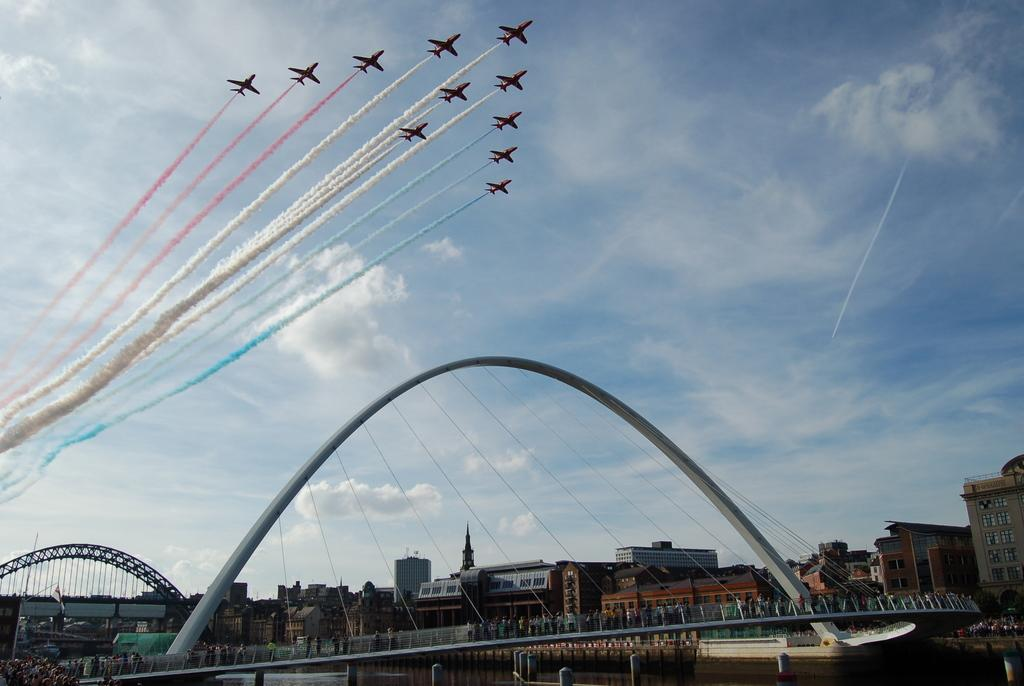What is happening with the flights in the image? The flights have different color smoke in the image. What structures can be seen at the bottom of the image? There are buildings and bridges with arches at the bottom of the image. What is visible in the background of the image? The sky is visible in the background of the image. What can be seen in the sky? Clouds are present in the sky. What type of pie is being served on the bridge in the image? There is no pie present in the image; it features flights with different color smoke, buildings, bridges with arches, and clouds in the sky. Can you tell me which pen is being used to draw the smoke trails in the image? There is no pen present in the image; the smoke trails are created by the flights themselves. 